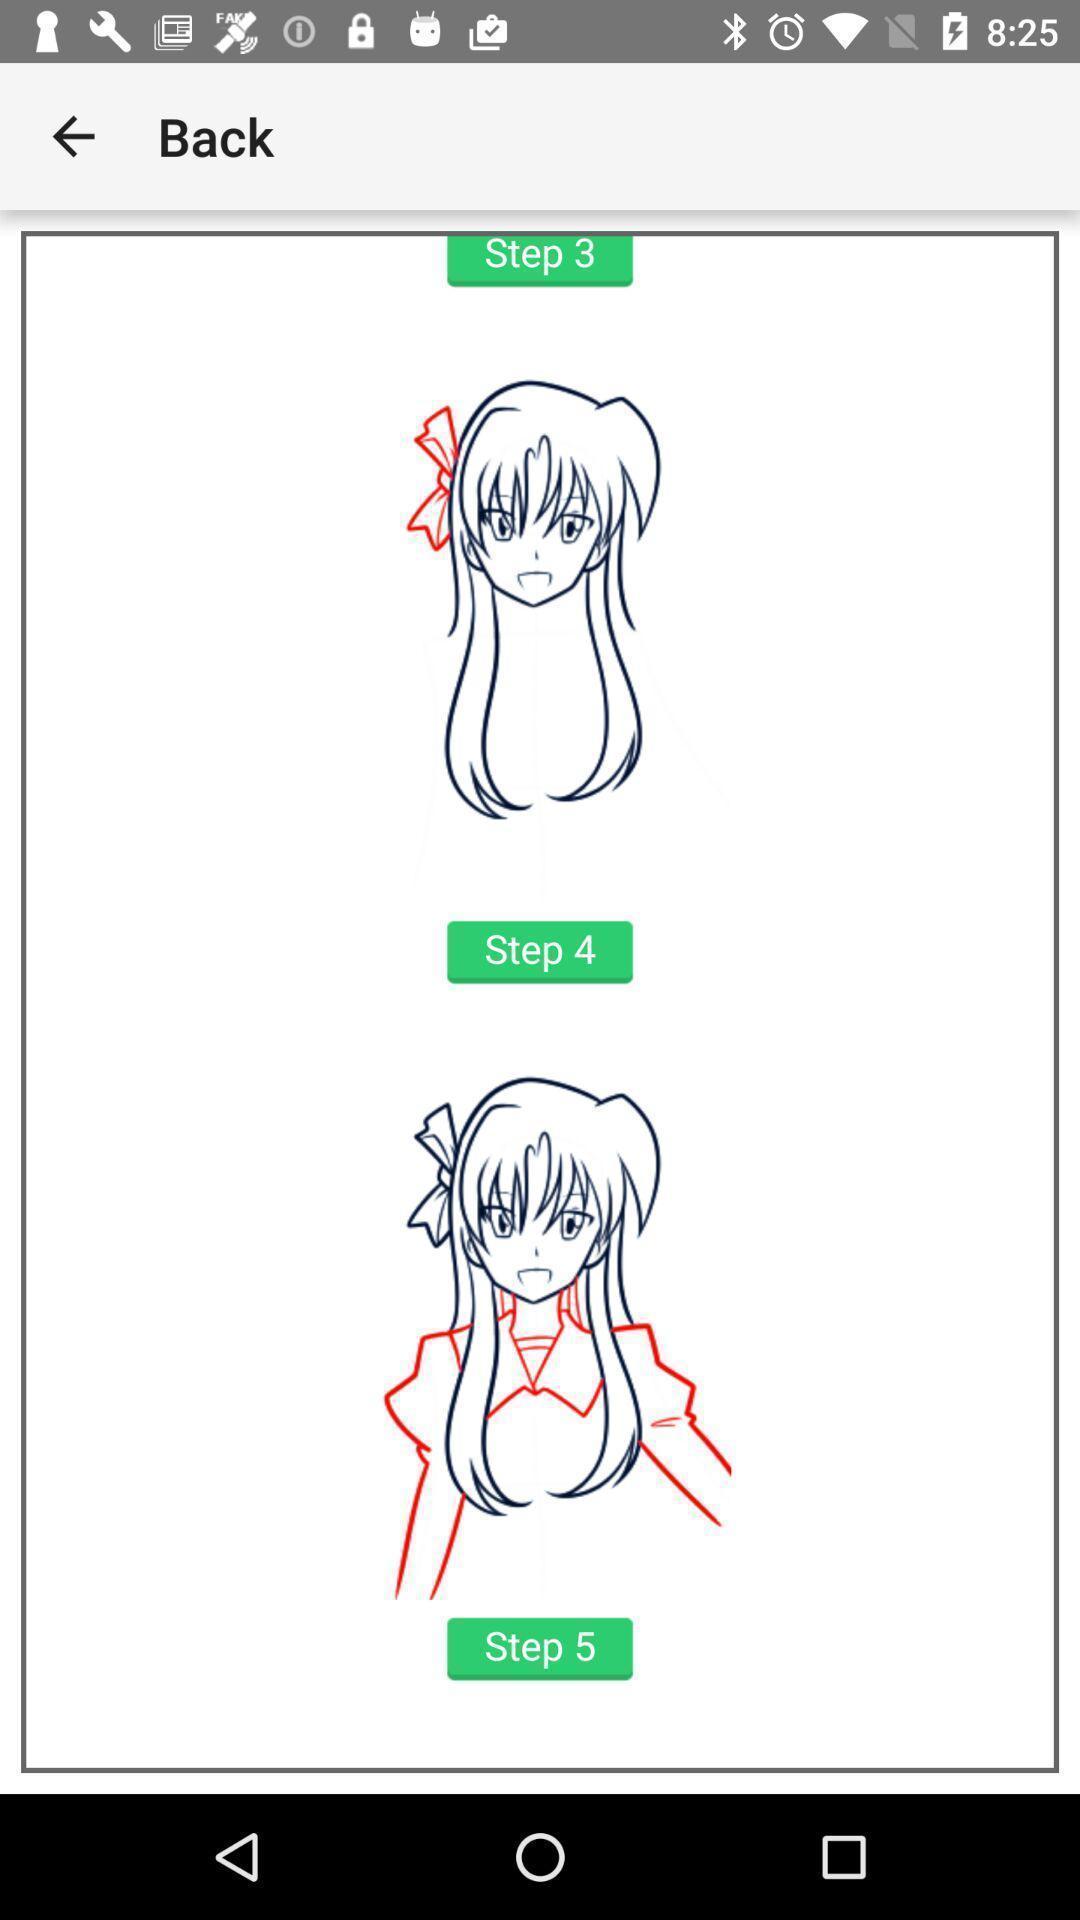Give me a narrative description of this picture. Page shows the different steps of images on drawing app. 